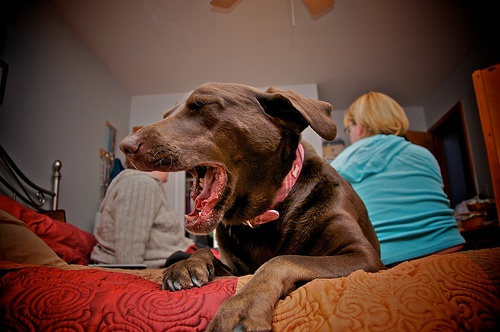Describe the objects in this image and their specific colors. I can see dog in black, maroon, and brown tones, bed in black, maroon, and brown tones, people in black and teal tones, and people in black and gray tones in this image. 